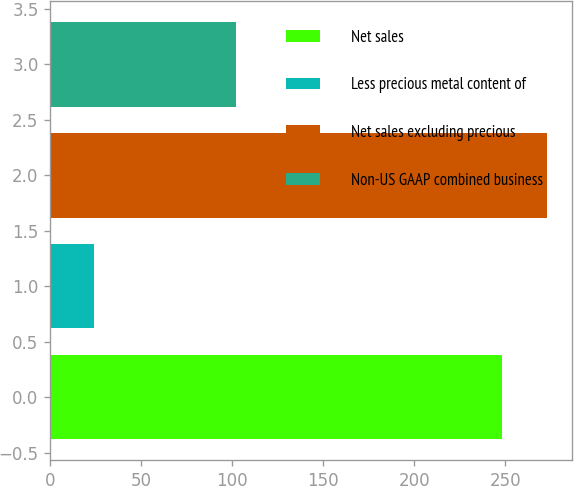<chart> <loc_0><loc_0><loc_500><loc_500><bar_chart><fcel>Net sales<fcel>Less precious metal content of<fcel>Net sales excluding precious<fcel>Non-US GAAP combined business<nl><fcel>248.1<fcel>23.8<fcel>272.91<fcel>102.2<nl></chart> 